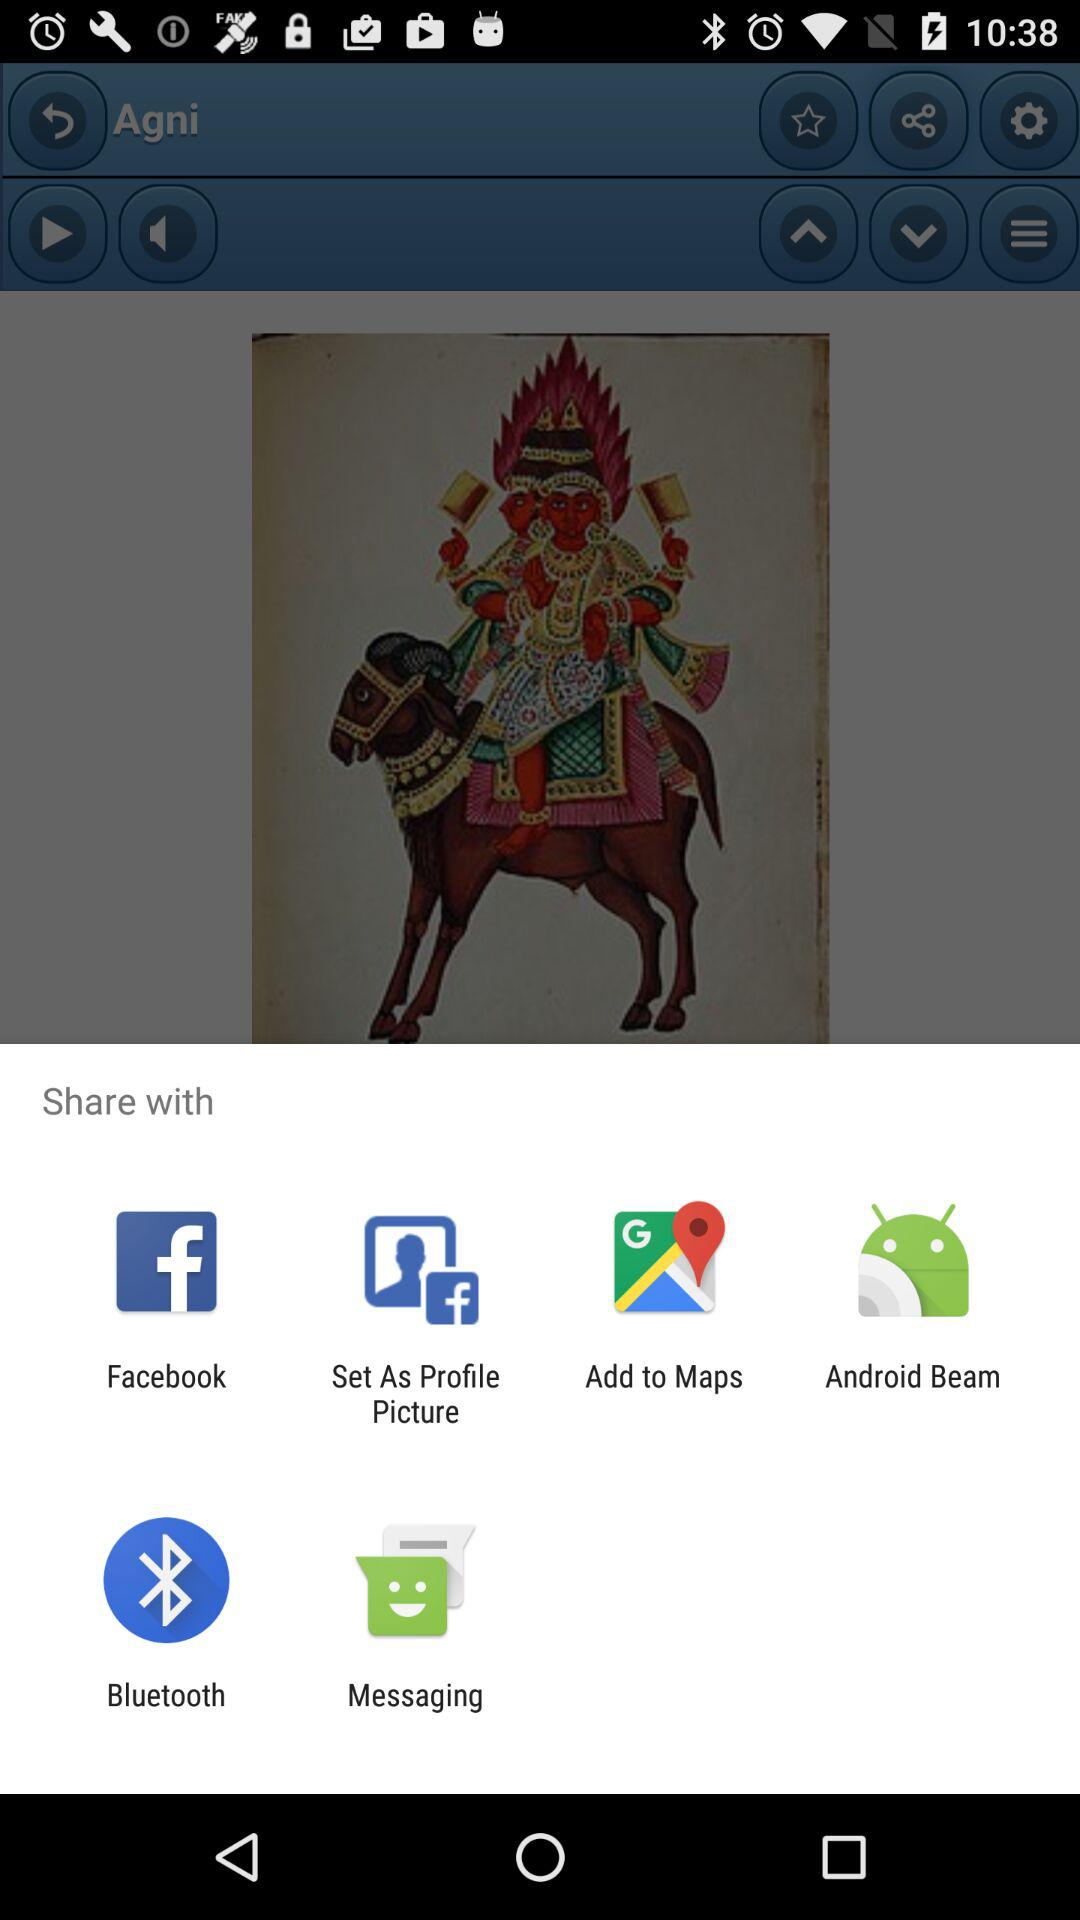What are the options to share? The sharing options are "Facebook", "Set As Profile Picture", "Add to Maps", "Android Beam", "Bluetooth", and "Messaging". 